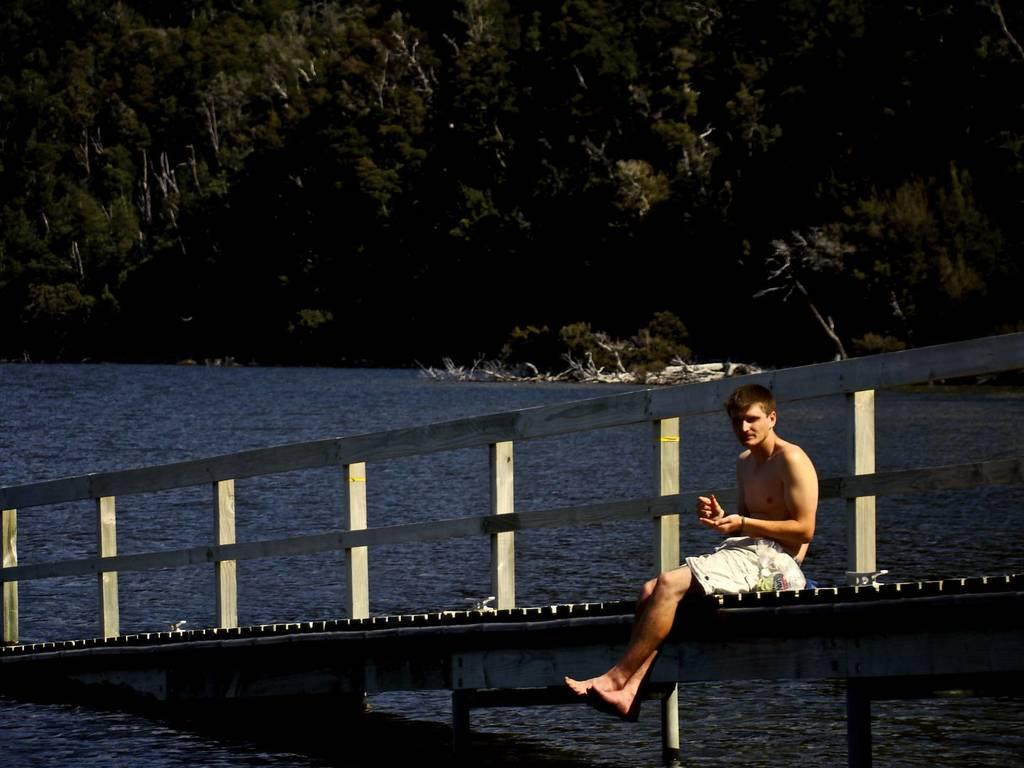Who is the main subject in the image? There is a boy in the image. What is the boy doing in the image? The boy is sitting on a bridge. What is the boy wearing in the image? The boy is not wearing a shirt. What can be seen under the bridge in the image? There is water under the bridge. What is visible in the background of the image? There are trees in the background of the image. What type of lace can be seen on the boy's shirt in the image? The boy is not wearing a shirt in the image, so there is no lace to be seen on his shirt. 